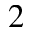<formula> <loc_0><loc_0><loc_500><loc_500>_ { 2 }</formula> 